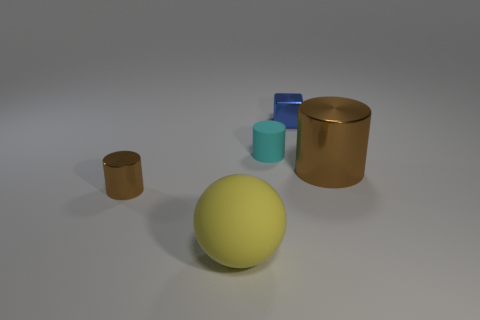Add 3 large things. How many objects exist? 8 Subtract all cubes. How many objects are left? 4 Subtract all matte cylinders. Subtract all small cyan matte cylinders. How many objects are left? 3 Add 2 brown shiny objects. How many brown shiny objects are left? 4 Add 3 gray metal cylinders. How many gray metal cylinders exist? 3 Subtract 0 green cylinders. How many objects are left? 5 